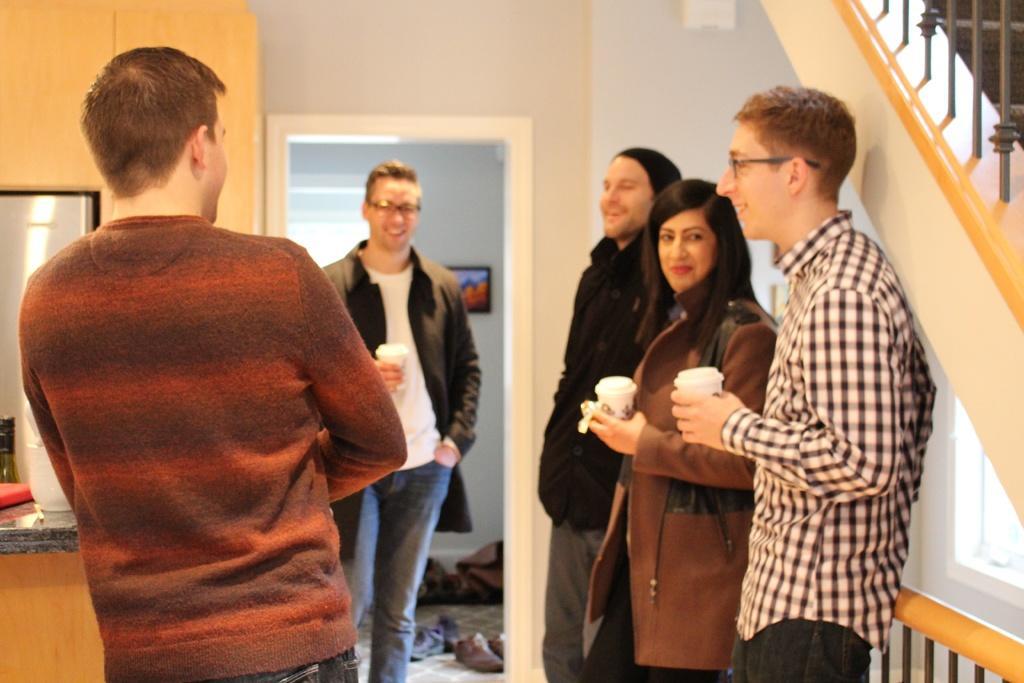In one or two sentences, can you explain what this image depicts? There are people standing and these three people are holding cups and we can see steps and objects on shelf. In the background we can see wall and another room,in this room we can see clothes on floor and frame on a wall. 